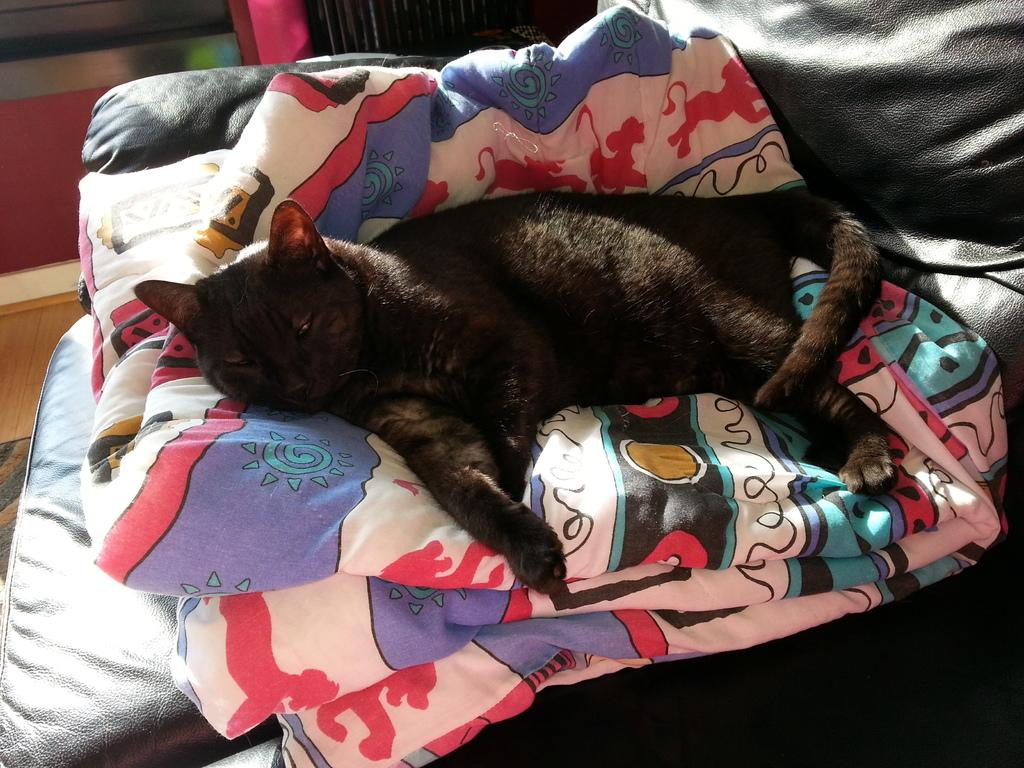What type of animal is in the image? There is a black cat in the image. What is the cat doing in the image? The cat is sleeping. What other object can be seen in the image besides the cat? There is a colorful cloth in the image. Where is the cloth placed in the image? The cloth is placed on a black leather sofa. What type of fuel is being used by the bikes in the image? There are no bikes present in the image, so it is not possible to determine what type of fuel is being used. 